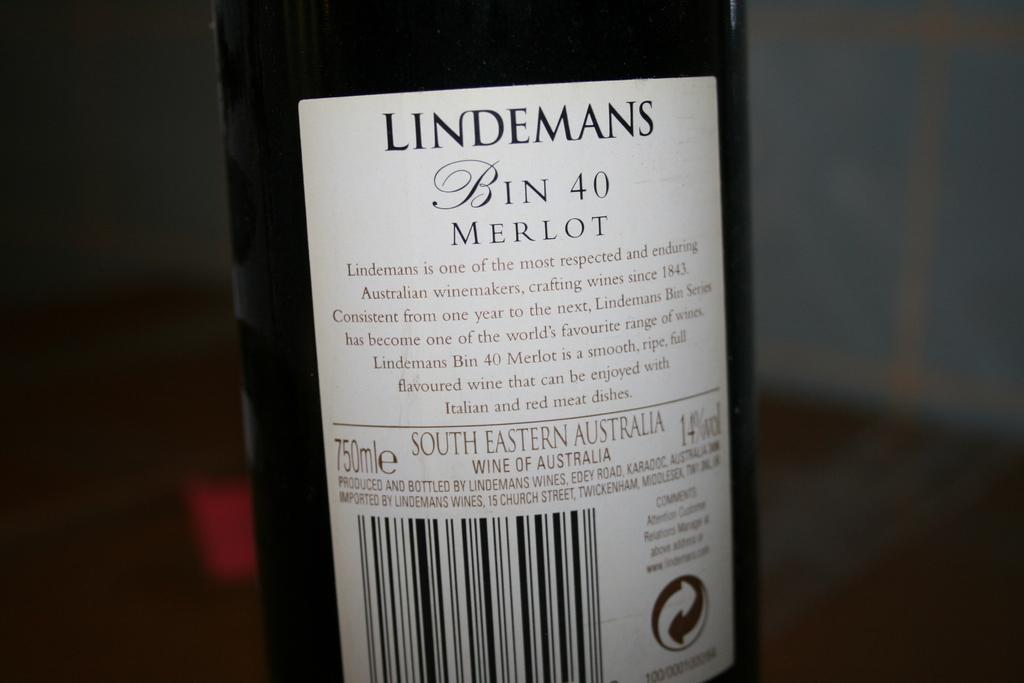<image>
Give a short and clear explanation of the subsequent image. the wine bottle is placed and the brand name is Lindemans bin 40 Merlot 